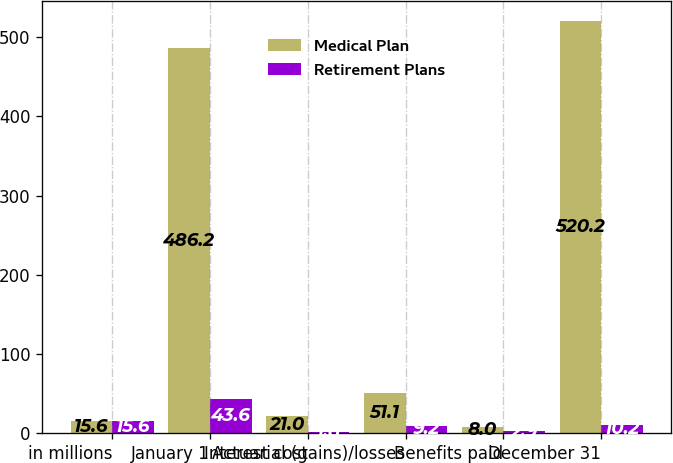<chart> <loc_0><loc_0><loc_500><loc_500><stacked_bar_chart><ecel><fcel>in millions<fcel>January 1<fcel>Interest cost<fcel>Actuarial (gains)/losses<fcel>Benefits paid<fcel>December 31<nl><fcel>Medical Plan<fcel>15.6<fcel>486.2<fcel>21<fcel>51.1<fcel>8<fcel>520.2<nl><fcel>Retirement Plans<fcel>15.6<fcel>43.6<fcel>1.8<fcel>9.2<fcel>2.9<fcel>10.2<nl></chart> 